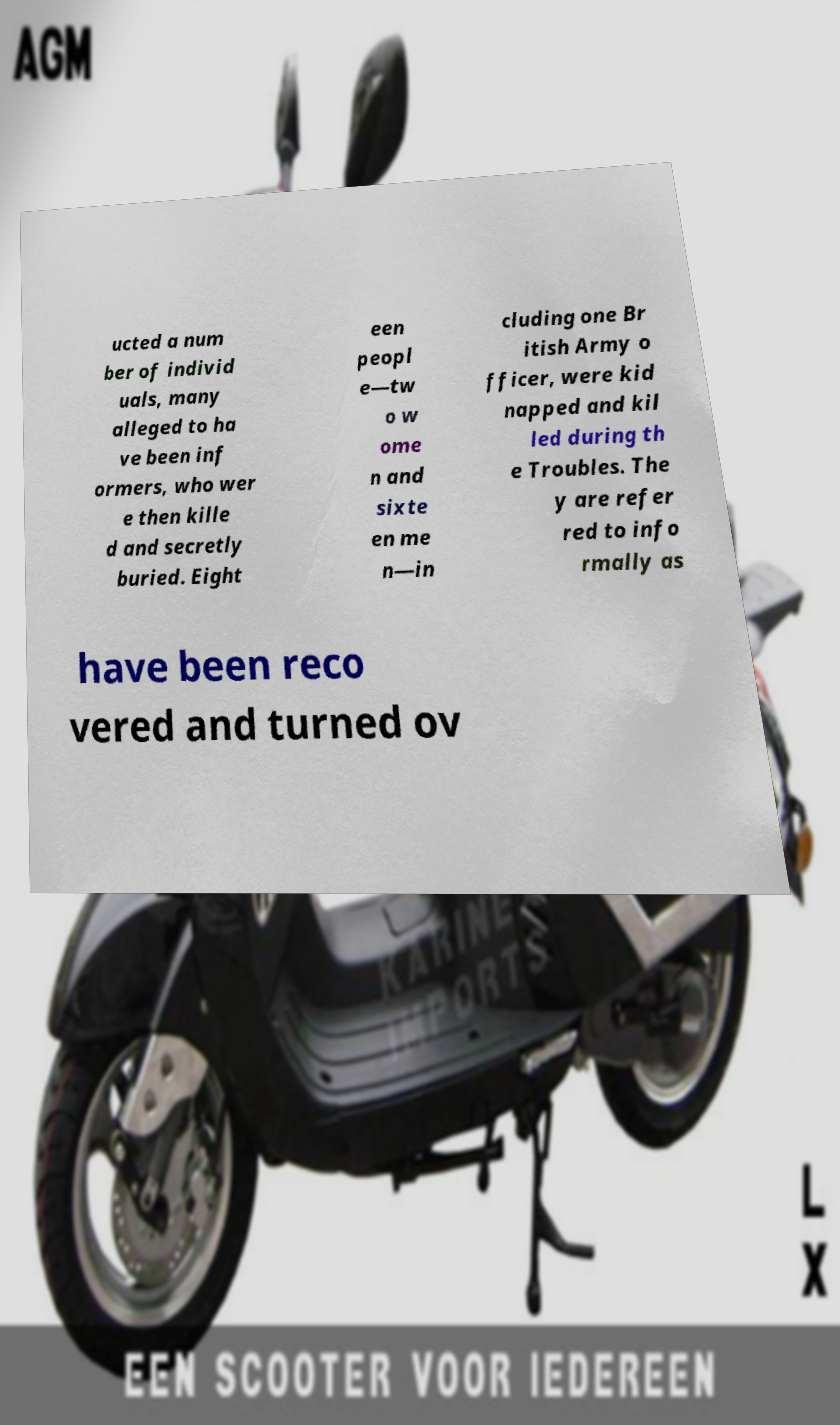Please read and relay the text visible in this image. What does it say? ucted a num ber of individ uals, many alleged to ha ve been inf ormers, who wer e then kille d and secretly buried. Eight een peopl e—tw o w ome n and sixte en me n—in cluding one Br itish Army o fficer, were kid napped and kil led during th e Troubles. The y are refer red to info rmally as have been reco vered and turned ov 